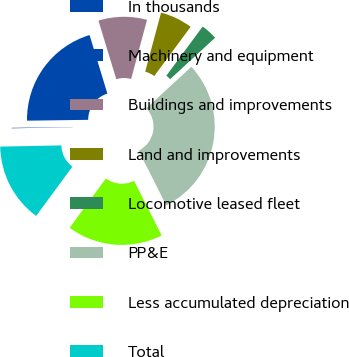Convert chart. <chart><loc_0><loc_0><loc_500><loc_500><pie_chart><fcel>In thousands<fcel>Machinery and equipment<fcel>Buildings and improvements<fcel>Land and improvements<fcel>Locomotive leased fleet<fcel>PP&E<fcel>Less accumulated depreciation<fcel>Total<nl><fcel>0.09%<fcel>20.52%<fcel>8.88%<fcel>5.95%<fcel>3.02%<fcel>29.41%<fcel>17.53%<fcel>14.6%<nl></chart> 